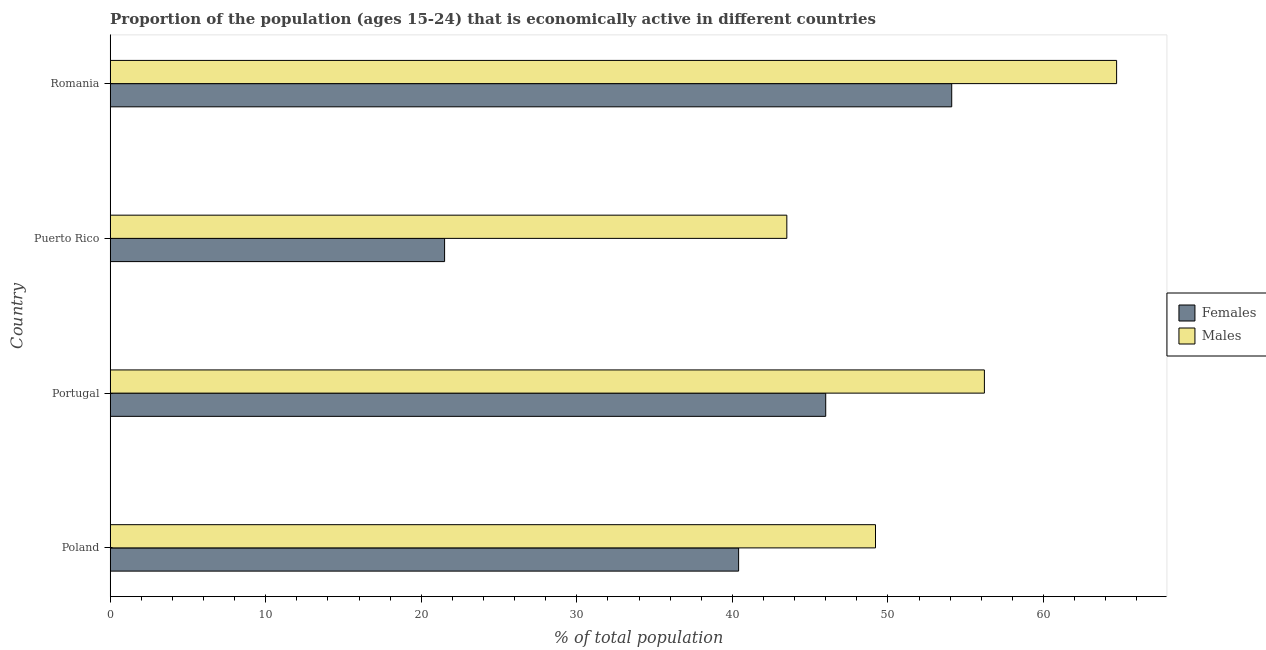How many different coloured bars are there?
Your response must be concise. 2. How many groups of bars are there?
Keep it short and to the point. 4. Are the number of bars per tick equal to the number of legend labels?
Provide a short and direct response. Yes. How many bars are there on the 2nd tick from the bottom?
Your answer should be very brief. 2. What is the label of the 3rd group of bars from the top?
Keep it short and to the point. Portugal. In how many cases, is the number of bars for a given country not equal to the number of legend labels?
Give a very brief answer. 0. What is the percentage of economically active female population in Romania?
Keep it short and to the point. 54.1. Across all countries, what is the maximum percentage of economically active female population?
Make the answer very short. 54.1. Across all countries, what is the minimum percentage of economically active male population?
Give a very brief answer. 43.5. In which country was the percentage of economically active female population maximum?
Provide a short and direct response. Romania. In which country was the percentage of economically active male population minimum?
Make the answer very short. Puerto Rico. What is the total percentage of economically active male population in the graph?
Provide a succinct answer. 213.6. What is the difference between the percentage of economically active female population in Romania and the percentage of economically active male population in Portugal?
Provide a short and direct response. -2.1. What is the average percentage of economically active male population per country?
Give a very brief answer. 53.4. What is the ratio of the percentage of economically active female population in Puerto Rico to that in Romania?
Your answer should be very brief. 0.4. Is the percentage of economically active male population in Poland less than that in Puerto Rico?
Make the answer very short. No. Is the difference between the percentage of economically active male population in Poland and Portugal greater than the difference between the percentage of economically active female population in Poland and Portugal?
Provide a succinct answer. No. What is the difference between the highest and the lowest percentage of economically active male population?
Ensure brevity in your answer.  21.2. Is the sum of the percentage of economically active male population in Portugal and Puerto Rico greater than the maximum percentage of economically active female population across all countries?
Keep it short and to the point. Yes. What does the 1st bar from the top in Romania represents?
Your answer should be compact. Males. What does the 1st bar from the bottom in Portugal represents?
Keep it short and to the point. Females. How many countries are there in the graph?
Offer a very short reply. 4. Where does the legend appear in the graph?
Your response must be concise. Center right. How are the legend labels stacked?
Provide a short and direct response. Vertical. What is the title of the graph?
Provide a short and direct response. Proportion of the population (ages 15-24) that is economically active in different countries. Does "Nitrous oxide emissions" appear as one of the legend labels in the graph?
Ensure brevity in your answer.  No. What is the label or title of the X-axis?
Keep it short and to the point. % of total population. What is the label or title of the Y-axis?
Keep it short and to the point. Country. What is the % of total population of Females in Poland?
Offer a terse response. 40.4. What is the % of total population in Males in Poland?
Provide a succinct answer. 49.2. What is the % of total population in Males in Portugal?
Your response must be concise. 56.2. What is the % of total population of Males in Puerto Rico?
Make the answer very short. 43.5. What is the % of total population in Females in Romania?
Make the answer very short. 54.1. What is the % of total population of Males in Romania?
Your answer should be compact. 64.7. Across all countries, what is the maximum % of total population of Females?
Provide a short and direct response. 54.1. Across all countries, what is the maximum % of total population in Males?
Offer a very short reply. 64.7. Across all countries, what is the minimum % of total population in Females?
Your answer should be very brief. 21.5. Across all countries, what is the minimum % of total population of Males?
Offer a terse response. 43.5. What is the total % of total population in Females in the graph?
Offer a very short reply. 162. What is the total % of total population in Males in the graph?
Your answer should be very brief. 213.6. What is the difference between the % of total population of Males in Poland and that in Portugal?
Provide a succinct answer. -7. What is the difference between the % of total population in Females in Poland and that in Puerto Rico?
Ensure brevity in your answer.  18.9. What is the difference between the % of total population in Females in Poland and that in Romania?
Make the answer very short. -13.7. What is the difference between the % of total population in Males in Poland and that in Romania?
Keep it short and to the point. -15.5. What is the difference between the % of total population in Males in Portugal and that in Puerto Rico?
Your answer should be very brief. 12.7. What is the difference between the % of total population of Males in Portugal and that in Romania?
Provide a short and direct response. -8.5. What is the difference between the % of total population in Females in Puerto Rico and that in Romania?
Your answer should be very brief. -32.6. What is the difference between the % of total population of Males in Puerto Rico and that in Romania?
Provide a short and direct response. -21.2. What is the difference between the % of total population in Females in Poland and the % of total population in Males in Portugal?
Provide a succinct answer. -15.8. What is the difference between the % of total population in Females in Poland and the % of total population in Males in Puerto Rico?
Your response must be concise. -3.1. What is the difference between the % of total population of Females in Poland and the % of total population of Males in Romania?
Ensure brevity in your answer.  -24.3. What is the difference between the % of total population in Females in Portugal and the % of total population in Males in Romania?
Offer a terse response. -18.7. What is the difference between the % of total population of Females in Puerto Rico and the % of total population of Males in Romania?
Keep it short and to the point. -43.2. What is the average % of total population in Females per country?
Make the answer very short. 40.5. What is the average % of total population of Males per country?
Offer a very short reply. 53.4. What is the difference between the % of total population in Females and % of total population in Males in Puerto Rico?
Your response must be concise. -22. What is the difference between the % of total population in Females and % of total population in Males in Romania?
Provide a succinct answer. -10.6. What is the ratio of the % of total population in Females in Poland to that in Portugal?
Make the answer very short. 0.88. What is the ratio of the % of total population in Males in Poland to that in Portugal?
Your response must be concise. 0.88. What is the ratio of the % of total population of Females in Poland to that in Puerto Rico?
Your answer should be very brief. 1.88. What is the ratio of the % of total population in Males in Poland to that in Puerto Rico?
Your response must be concise. 1.13. What is the ratio of the % of total population of Females in Poland to that in Romania?
Provide a short and direct response. 0.75. What is the ratio of the % of total population in Males in Poland to that in Romania?
Provide a succinct answer. 0.76. What is the ratio of the % of total population in Females in Portugal to that in Puerto Rico?
Make the answer very short. 2.14. What is the ratio of the % of total population of Males in Portugal to that in Puerto Rico?
Your answer should be compact. 1.29. What is the ratio of the % of total population of Females in Portugal to that in Romania?
Your response must be concise. 0.85. What is the ratio of the % of total population of Males in Portugal to that in Romania?
Offer a very short reply. 0.87. What is the ratio of the % of total population of Females in Puerto Rico to that in Romania?
Make the answer very short. 0.4. What is the ratio of the % of total population in Males in Puerto Rico to that in Romania?
Give a very brief answer. 0.67. What is the difference between the highest and the second highest % of total population in Females?
Ensure brevity in your answer.  8.1. What is the difference between the highest and the lowest % of total population of Females?
Ensure brevity in your answer.  32.6. What is the difference between the highest and the lowest % of total population of Males?
Provide a succinct answer. 21.2. 